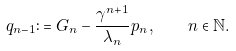<formula> <loc_0><loc_0><loc_500><loc_500>q _ { n - 1 } \colon = G _ { n } - \frac { \gamma ^ { n + 1 } } { \lambda _ { n } } p _ { n } , \quad n \in \mathbb { N } .</formula> 